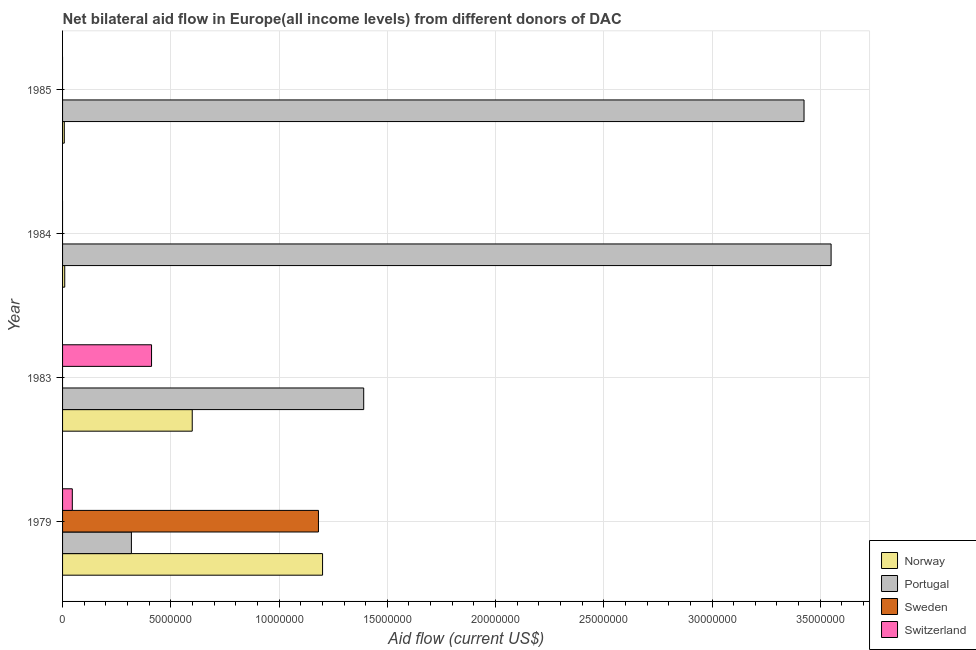How many different coloured bars are there?
Provide a short and direct response. 4. How many bars are there on the 1st tick from the bottom?
Your answer should be compact. 4. In how many cases, is the number of bars for a given year not equal to the number of legend labels?
Your answer should be compact. 3. Across all years, what is the maximum amount of aid given by norway?
Give a very brief answer. 1.20e+07. Across all years, what is the minimum amount of aid given by norway?
Ensure brevity in your answer.  8.00e+04. In which year was the amount of aid given by norway maximum?
Keep it short and to the point. 1979. What is the total amount of aid given by sweden in the graph?
Make the answer very short. 1.18e+07. What is the difference between the amount of aid given by norway in 1979 and that in 1983?
Offer a terse response. 6.02e+06. What is the difference between the amount of aid given by norway in 1985 and the amount of aid given by switzerland in 1983?
Keep it short and to the point. -4.03e+06. What is the average amount of aid given by portugal per year?
Your answer should be very brief. 2.17e+07. In the year 1979, what is the difference between the amount of aid given by norway and amount of aid given by portugal?
Your response must be concise. 8.83e+06. In how many years, is the amount of aid given by sweden greater than 28000000 US$?
Make the answer very short. 0. What is the ratio of the amount of aid given by portugal in 1983 to that in 1985?
Your response must be concise. 0.41. Is the amount of aid given by portugal in 1983 less than that in 1985?
Provide a succinct answer. Yes. What is the difference between the highest and the second highest amount of aid given by portugal?
Keep it short and to the point. 1.25e+06. What is the difference between the highest and the lowest amount of aid given by switzerland?
Provide a short and direct response. 4.11e+06. In how many years, is the amount of aid given by portugal greater than the average amount of aid given by portugal taken over all years?
Offer a terse response. 2. Is the sum of the amount of aid given by portugal in 1983 and 1985 greater than the maximum amount of aid given by sweden across all years?
Provide a short and direct response. Yes. Is it the case that in every year, the sum of the amount of aid given by norway and amount of aid given by switzerland is greater than the sum of amount of aid given by sweden and amount of aid given by portugal?
Provide a short and direct response. No. Is it the case that in every year, the sum of the amount of aid given by norway and amount of aid given by portugal is greater than the amount of aid given by sweden?
Ensure brevity in your answer.  Yes. How many years are there in the graph?
Offer a terse response. 4. What is the difference between two consecutive major ticks on the X-axis?
Your answer should be very brief. 5.00e+06. Where does the legend appear in the graph?
Give a very brief answer. Bottom right. How many legend labels are there?
Provide a short and direct response. 4. What is the title of the graph?
Offer a very short reply. Net bilateral aid flow in Europe(all income levels) from different donors of DAC. Does "Taxes on income" appear as one of the legend labels in the graph?
Offer a terse response. No. What is the Aid flow (current US$) in Norway in 1979?
Give a very brief answer. 1.20e+07. What is the Aid flow (current US$) in Portugal in 1979?
Offer a very short reply. 3.18e+06. What is the Aid flow (current US$) of Sweden in 1979?
Give a very brief answer. 1.18e+07. What is the Aid flow (current US$) in Switzerland in 1979?
Make the answer very short. 4.50e+05. What is the Aid flow (current US$) of Norway in 1983?
Provide a succinct answer. 5.99e+06. What is the Aid flow (current US$) in Portugal in 1983?
Offer a very short reply. 1.39e+07. What is the Aid flow (current US$) of Sweden in 1983?
Give a very brief answer. 0. What is the Aid flow (current US$) of Switzerland in 1983?
Offer a very short reply. 4.11e+06. What is the Aid flow (current US$) in Norway in 1984?
Provide a succinct answer. 1.00e+05. What is the Aid flow (current US$) of Portugal in 1984?
Offer a terse response. 3.55e+07. What is the Aid flow (current US$) in Norway in 1985?
Make the answer very short. 8.00e+04. What is the Aid flow (current US$) in Portugal in 1985?
Keep it short and to the point. 3.42e+07. What is the Aid flow (current US$) of Sweden in 1985?
Give a very brief answer. 0. Across all years, what is the maximum Aid flow (current US$) in Norway?
Give a very brief answer. 1.20e+07. Across all years, what is the maximum Aid flow (current US$) of Portugal?
Provide a succinct answer. 3.55e+07. Across all years, what is the maximum Aid flow (current US$) in Sweden?
Provide a short and direct response. 1.18e+07. Across all years, what is the maximum Aid flow (current US$) of Switzerland?
Your answer should be compact. 4.11e+06. Across all years, what is the minimum Aid flow (current US$) of Portugal?
Make the answer very short. 3.18e+06. Across all years, what is the minimum Aid flow (current US$) of Sweden?
Provide a short and direct response. 0. What is the total Aid flow (current US$) in Norway in the graph?
Make the answer very short. 1.82e+07. What is the total Aid flow (current US$) of Portugal in the graph?
Provide a short and direct response. 8.68e+07. What is the total Aid flow (current US$) in Sweden in the graph?
Keep it short and to the point. 1.18e+07. What is the total Aid flow (current US$) in Switzerland in the graph?
Offer a very short reply. 4.56e+06. What is the difference between the Aid flow (current US$) in Norway in 1979 and that in 1983?
Keep it short and to the point. 6.02e+06. What is the difference between the Aid flow (current US$) of Portugal in 1979 and that in 1983?
Your answer should be very brief. -1.07e+07. What is the difference between the Aid flow (current US$) in Switzerland in 1979 and that in 1983?
Provide a succinct answer. -3.66e+06. What is the difference between the Aid flow (current US$) in Norway in 1979 and that in 1984?
Provide a succinct answer. 1.19e+07. What is the difference between the Aid flow (current US$) of Portugal in 1979 and that in 1984?
Offer a very short reply. -3.23e+07. What is the difference between the Aid flow (current US$) in Norway in 1979 and that in 1985?
Keep it short and to the point. 1.19e+07. What is the difference between the Aid flow (current US$) of Portugal in 1979 and that in 1985?
Offer a very short reply. -3.11e+07. What is the difference between the Aid flow (current US$) of Norway in 1983 and that in 1984?
Provide a succinct answer. 5.89e+06. What is the difference between the Aid flow (current US$) in Portugal in 1983 and that in 1984?
Offer a very short reply. -2.16e+07. What is the difference between the Aid flow (current US$) of Norway in 1983 and that in 1985?
Offer a terse response. 5.91e+06. What is the difference between the Aid flow (current US$) of Portugal in 1983 and that in 1985?
Provide a succinct answer. -2.03e+07. What is the difference between the Aid flow (current US$) in Norway in 1984 and that in 1985?
Provide a short and direct response. 2.00e+04. What is the difference between the Aid flow (current US$) of Portugal in 1984 and that in 1985?
Provide a succinct answer. 1.25e+06. What is the difference between the Aid flow (current US$) of Norway in 1979 and the Aid flow (current US$) of Portugal in 1983?
Provide a succinct answer. -1.90e+06. What is the difference between the Aid flow (current US$) in Norway in 1979 and the Aid flow (current US$) in Switzerland in 1983?
Your response must be concise. 7.90e+06. What is the difference between the Aid flow (current US$) in Portugal in 1979 and the Aid flow (current US$) in Switzerland in 1983?
Your response must be concise. -9.30e+05. What is the difference between the Aid flow (current US$) of Sweden in 1979 and the Aid flow (current US$) of Switzerland in 1983?
Provide a short and direct response. 7.71e+06. What is the difference between the Aid flow (current US$) of Norway in 1979 and the Aid flow (current US$) of Portugal in 1984?
Make the answer very short. -2.35e+07. What is the difference between the Aid flow (current US$) of Norway in 1979 and the Aid flow (current US$) of Portugal in 1985?
Your response must be concise. -2.22e+07. What is the difference between the Aid flow (current US$) of Norway in 1983 and the Aid flow (current US$) of Portugal in 1984?
Make the answer very short. -2.95e+07. What is the difference between the Aid flow (current US$) in Norway in 1983 and the Aid flow (current US$) in Portugal in 1985?
Offer a terse response. -2.83e+07. What is the difference between the Aid flow (current US$) in Norway in 1984 and the Aid flow (current US$) in Portugal in 1985?
Your response must be concise. -3.42e+07. What is the average Aid flow (current US$) in Norway per year?
Your answer should be very brief. 4.54e+06. What is the average Aid flow (current US$) in Portugal per year?
Give a very brief answer. 2.17e+07. What is the average Aid flow (current US$) of Sweden per year?
Keep it short and to the point. 2.96e+06. What is the average Aid flow (current US$) of Switzerland per year?
Keep it short and to the point. 1.14e+06. In the year 1979, what is the difference between the Aid flow (current US$) of Norway and Aid flow (current US$) of Portugal?
Ensure brevity in your answer.  8.83e+06. In the year 1979, what is the difference between the Aid flow (current US$) of Norway and Aid flow (current US$) of Switzerland?
Your answer should be compact. 1.16e+07. In the year 1979, what is the difference between the Aid flow (current US$) of Portugal and Aid flow (current US$) of Sweden?
Provide a short and direct response. -8.64e+06. In the year 1979, what is the difference between the Aid flow (current US$) of Portugal and Aid flow (current US$) of Switzerland?
Provide a succinct answer. 2.73e+06. In the year 1979, what is the difference between the Aid flow (current US$) of Sweden and Aid flow (current US$) of Switzerland?
Your response must be concise. 1.14e+07. In the year 1983, what is the difference between the Aid flow (current US$) of Norway and Aid flow (current US$) of Portugal?
Ensure brevity in your answer.  -7.92e+06. In the year 1983, what is the difference between the Aid flow (current US$) in Norway and Aid flow (current US$) in Switzerland?
Ensure brevity in your answer.  1.88e+06. In the year 1983, what is the difference between the Aid flow (current US$) of Portugal and Aid flow (current US$) of Switzerland?
Ensure brevity in your answer.  9.80e+06. In the year 1984, what is the difference between the Aid flow (current US$) in Norway and Aid flow (current US$) in Portugal?
Ensure brevity in your answer.  -3.54e+07. In the year 1985, what is the difference between the Aid flow (current US$) of Norway and Aid flow (current US$) of Portugal?
Your answer should be very brief. -3.42e+07. What is the ratio of the Aid flow (current US$) in Norway in 1979 to that in 1983?
Give a very brief answer. 2. What is the ratio of the Aid flow (current US$) of Portugal in 1979 to that in 1983?
Offer a terse response. 0.23. What is the ratio of the Aid flow (current US$) in Switzerland in 1979 to that in 1983?
Keep it short and to the point. 0.11. What is the ratio of the Aid flow (current US$) of Norway in 1979 to that in 1984?
Keep it short and to the point. 120.1. What is the ratio of the Aid flow (current US$) of Portugal in 1979 to that in 1984?
Offer a terse response. 0.09. What is the ratio of the Aid flow (current US$) of Norway in 1979 to that in 1985?
Offer a very short reply. 150.12. What is the ratio of the Aid flow (current US$) in Portugal in 1979 to that in 1985?
Provide a short and direct response. 0.09. What is the ratio of the Aid flow (current US$) of Norway in 1983 to that in 1984?
Offer a very short reply. 59.9. What is the ratio of the Aid flow (current US$) in Portugal in 1983 to that in 1984?
Your answer should be very brief. 0.39. What is the ratio of the Aid flow (current US$) in Norway in 1983 to that in 1985?
Your answer should be compact. 74.88. What is the ratio of the Aid flow (current US$) in Portugal in 1983 to that in 1985?
Offer a very short reply. 0.41. What is the ratio of the Aid flow (current US$) in Portugal in 1984 to that in 1985?
Your response must be concise. 1.04. What is the difference between the highest and the second highest Aid flow (current US$) of Norway?
Give a very brief answer. 6.02e+06. What is the difference between the highest and the second highest Aid flow (current US$) in Portugal?
Keep it short and to the point. 1.25e+06. What is the difference between the highest and the lowest Aid flow (current US$) of Norway?
Your answer should be very brief. 1.19e+07. What is the difference between the highest and the lowest Aid flow (current US$) in Portugal?
Provide a short and direct response. 3.23e+07. What is the difference between the highest and the lowest Aid flow (current US$) of Sweden?
Your answer should be very brief. 1.18e+07. What is the difference between the highest and the lowest Aid flow (current US$) of Switzerland?
Provide a succinct answer. 4.11e+06. 